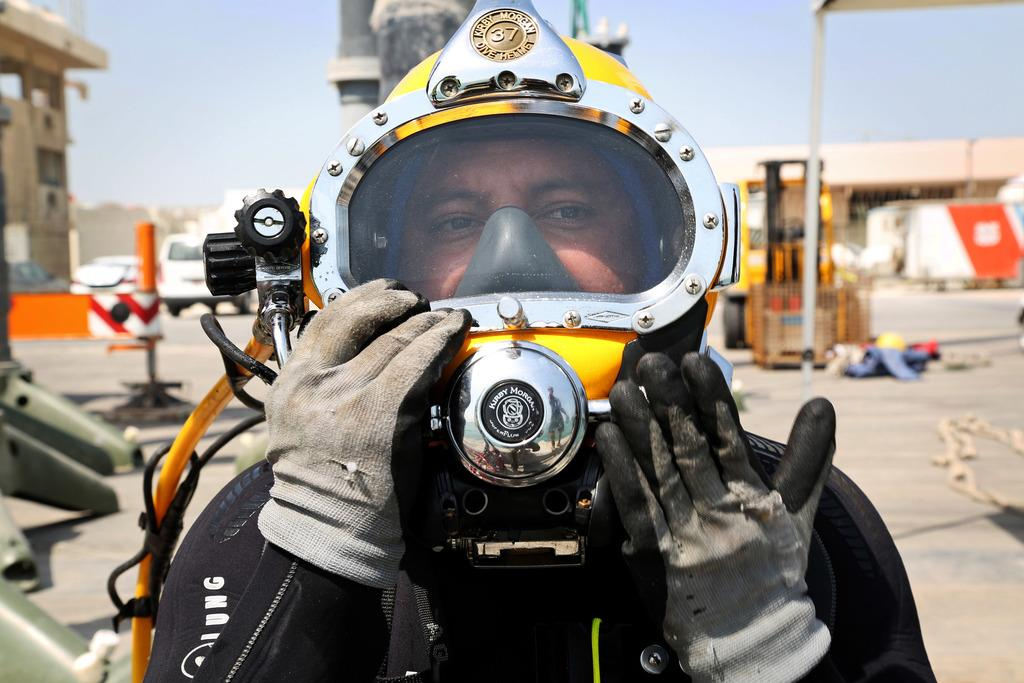What is the person in the image wearing on their head? The person is wearing a firefighter's helmet. What type of clothing is the person wearing on their hands? The person is wearing gloves. What can be seen in the background of the image? There is sky, vehicles, at least one building, a house, poles, and other objects visible in the background of the image. What type of sink can be seen in the image? There is no sink present in the image. What war is the person in the image participating in? There is no indication of a war or any conflict in the image. What songs is the person in the image singing? There is no indication that the person is singing any songs in the image. 